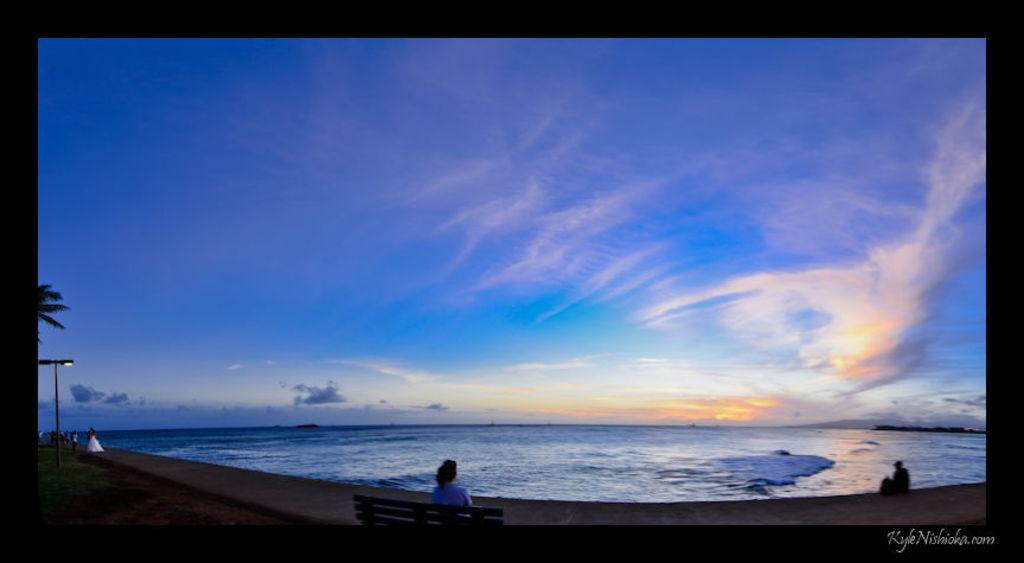<image>
Describe the image concisely. A screen is showing an image of a beach and horizon has the web address, 'KyleNishioka.com'. 